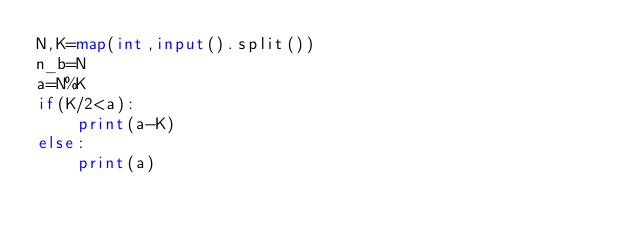Convert code to text. <code><loc_0><loc_0><loc_500><loc_500><_Python_>N,K=map(int,input().split())
n_b=N
a=N%K
if(K/2<a):
    print(a-K)
else:
    print(a)
</code> 